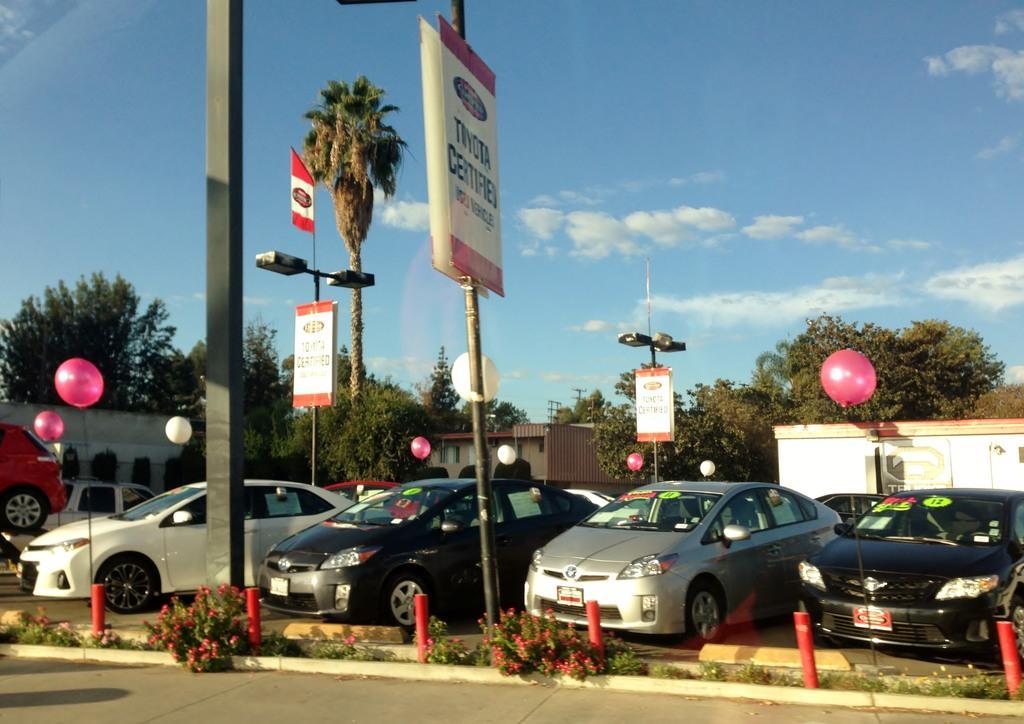How would you summarize this image in a sentence or two? Here in this picture we can see number of cars present on the ground over there and we can see balloons, hoardings, light posts present here and there and behind that we can see some stores present and we can also see plants and trees present all over there and in the middle we can see flag post and we can also see clouds in the sky. 